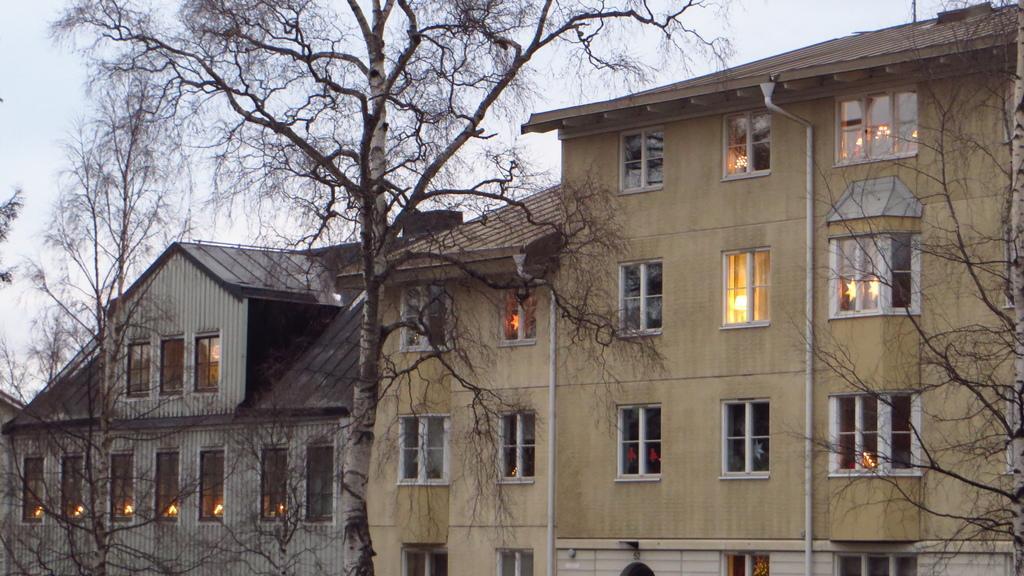How would you summarize this image in a sentence or two? In this picture we can see a few trees on the right and left side of the image. There are some lights visible in the buildings. We can see the sky on top of the picture. 